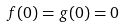<formula> <loc_0><loc_0><loc_500><loc_500>f ( 0 ) = g ( 0 ) = 0</formula> 